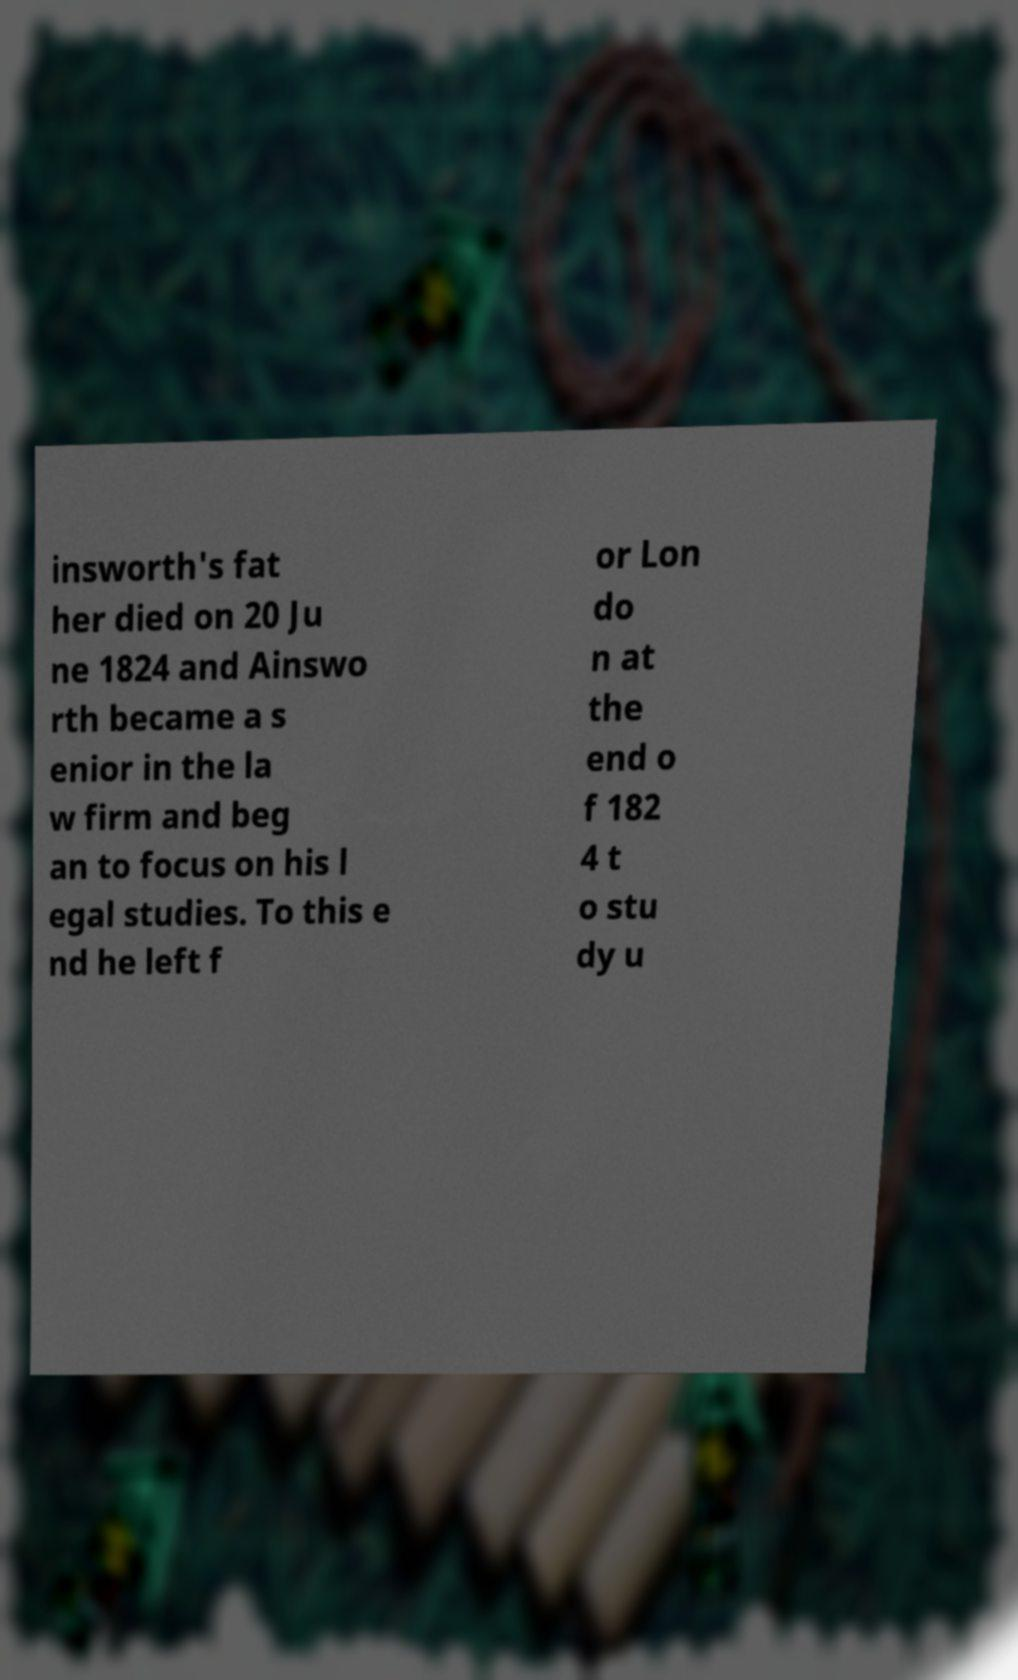Can you read and provide the text displayed in the image?This photo seems to have some interesting text. Can you extract and type it out for me? insworth's fat her died on 20 Ju ne 1824 and Ainswo rth became a s enior in the la w firm and beg an to focus on his l egal studies. To this e nd he left f or Lon do n at the end o f 182 4 t o stu dy u 